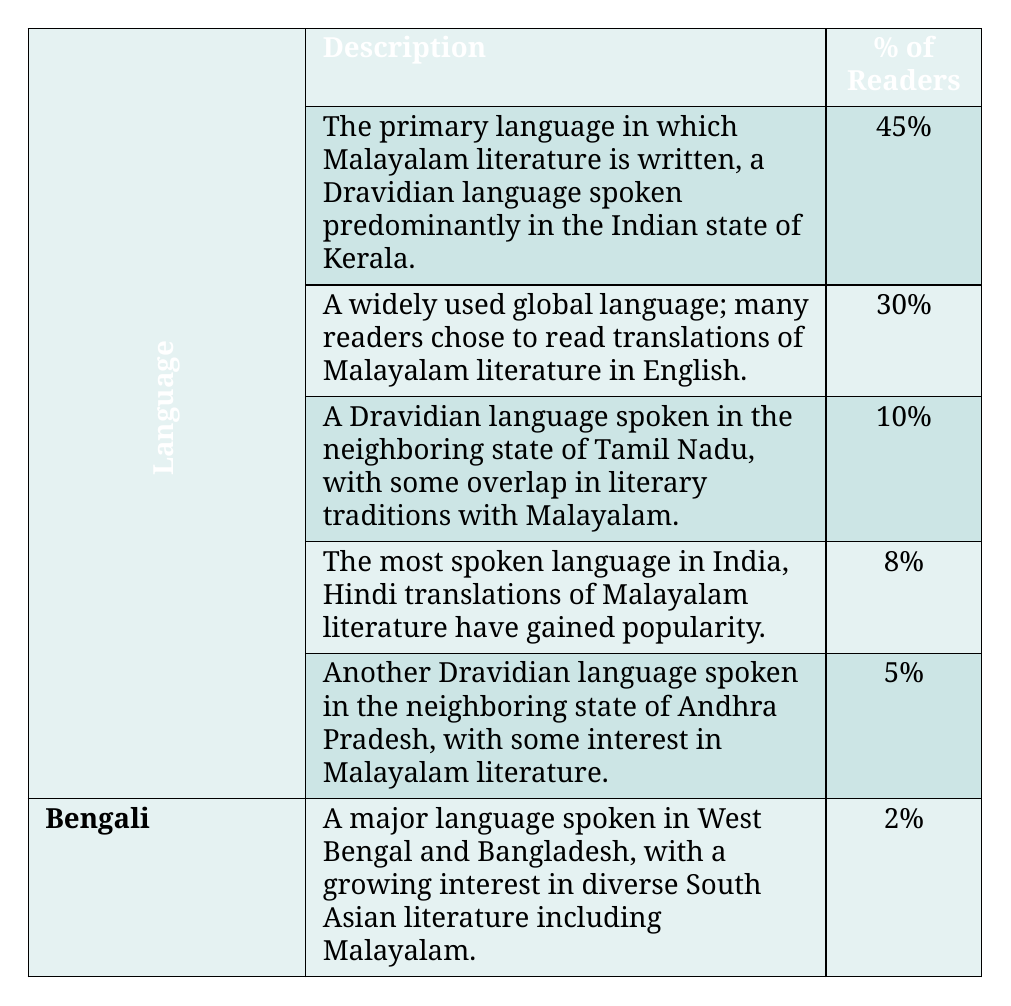What is the percentage of readers who speak Malayalam? The table states that **Malayalam** is spoken by **45%** of readers.
Answer: 45% Which language has the highest percentage of readers? According to the table, **Malayalam** has the highest percentage of readers, at **45%**.
Answer: Malayalam How many readers speak English compared to Tamil? **30%** of readers speak **English**, while **10%** speak **Tamil**. The difference is **20%**.
Answer: 20% Is the percentage of readers who speak Hindi more than those who speak Telugu? The table shows that **8%** of readers speak **Hindi**, while **5%** speak **Telugu**. Since **8%** is greater than **5%**, the statement is true.
Answer: Yes What is the combined percentage of readers who speak Tamil and Hindi? To find the combined percentage, add the two percentages: **10%** (Tamil) + **8%** (Hindi) = **18%**.
Answer: 18% Which two languages have the least percentage of readers, and what are their values? The table indicates that **Bengali** has **2%**, and **Telugu** has **5%**, making them the least spoken languages among the readers.
Answer: Bengali (2%), Telugu (5%) If you consider all the languages spoken by readers, what percentage do readers who speak Tamil or higher represent? The percentages for languages that fall under Tamil or higher (Malayalam, English, Tamil) are **45%**, **30%**, and **10%**, totaling **85%**.
Answer: 85% Is there a language with more than 25% of readers? The table shows that only **Malayalam** and **English** exceed **25%**, with **45%** and **30%** respectively, confirming that there are languages with more than **25%** of readers.
Answer: Yes How many readers in total speak languages that have more than 10% share? The languages with more than **10%** are **Malayalam** (45%), **English** (30%), and **Tamil** (10%): Adding these gives **45 + 30 + 10 = 85%**.
Answer: 85% If a new survey found that the percentage of readers speaking Bengali increased to 5%, how would that affect the total percentage of readers? With **2%** currently for Bengali, increasing it to **5%** would raise the overall readership by a total of **3%**. The sum of all percentages will still equal **100%**, but distributions for other languages must be looked at more closely to understand how they change.
Answer: 3% increase in Bengali's readership 